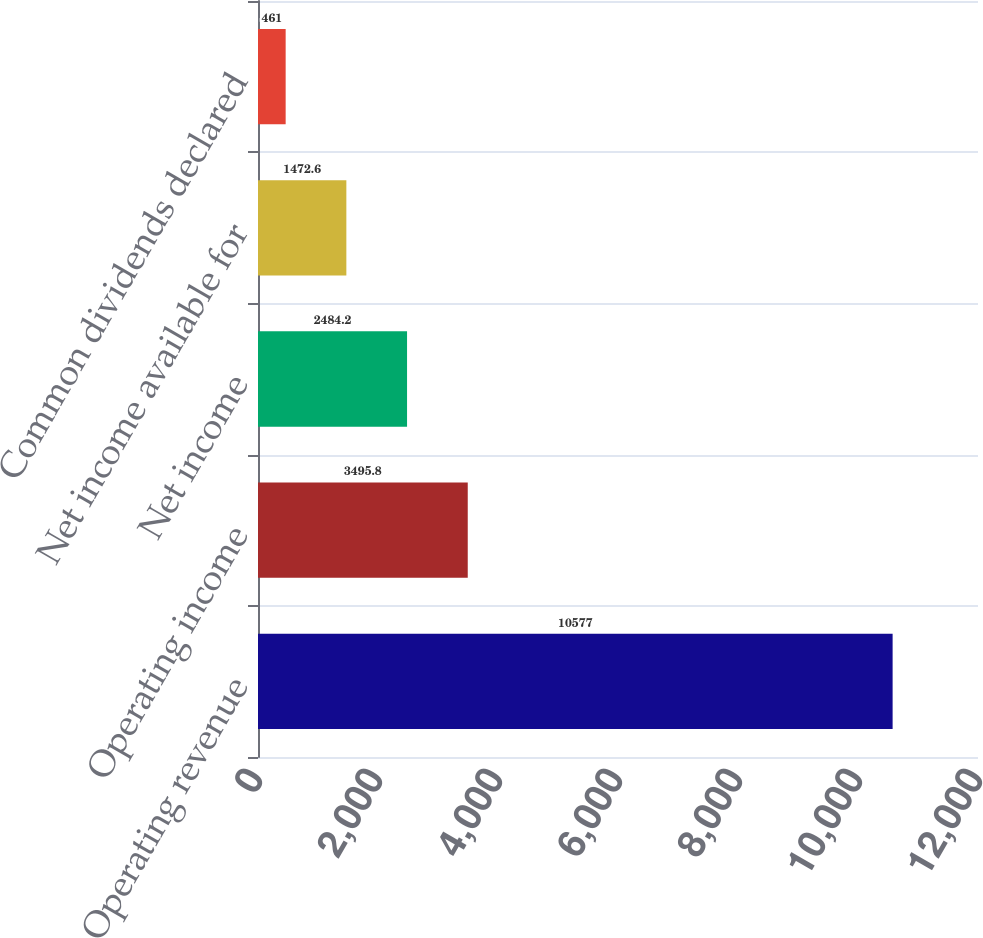<chart> <loc_0><loc_0><loc_500><loc_500><bar_chart><fcel>Operating revenue<fcel>Operating income<fcel>Net income<fcel>Net income available for<fcel>Common dividends declared<nl><fcel>10577<fcel>3495.8<fcel>2484.2<fcel>1472.6<fcel>461<nl></chart> 